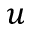Convert formula to latex. <formula><loc_0><loc_0><loc_500><loc_500>u</formula> 